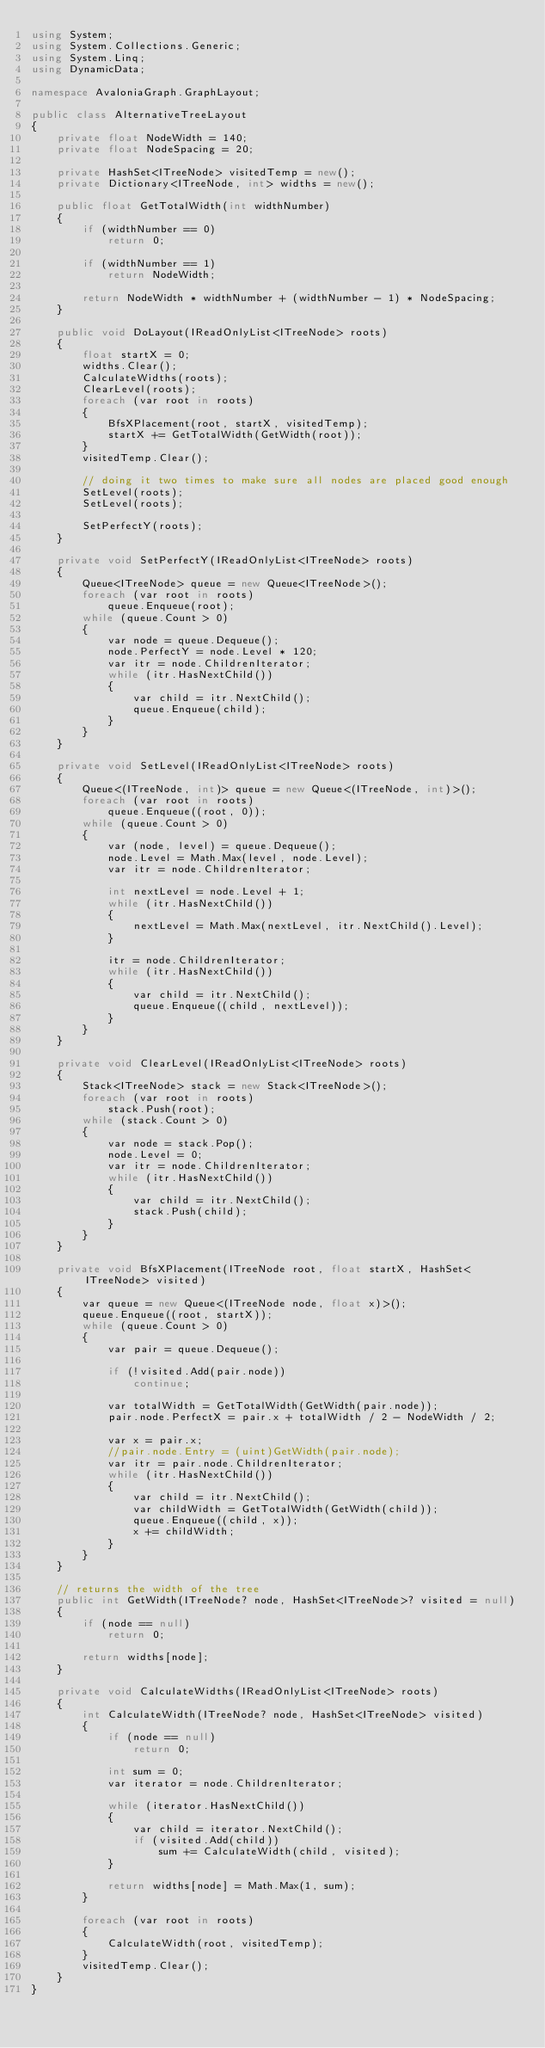Convert code to text. <code><loc_0><loc_0><loc_500><loc_500><_C#_>using System;
using System.Collections.Generic;
using System.Linq;
using DynamicData;

namespace AvaloniaGraph.GraphLayout;

public class AlternativeTreeLayout
{
    private float NodeWidth = 140;
    private float NodeSpacing = 20;

    private HashSet<ITreeNode> visitedTemp = new();
    private Dictionary<ITreeNode, int> widths = new();

    public float GetTotalWidth(int widthNumber)
    {
        if (widthNumber == 0)
            return 0;
        
        if (widthNumber == 1)
            return NodeWidth;

        return NodeWidth * widthNumber + (widthNumber - 1) * NodeSpacing;
    }
    
    public void DoLayout(IReadOnlyList<ITreeNode> roots)
    {
        float startX = 0;
        widths.Clear();
        CalculateWidths(roots);
        ClearLevel(roots);
        foreach (var root in roots)
        {
            BfsXPlacement(root, startX, visitedTemp);
            startX += GetTotalWidth(GetWidth(root));
        }
        visitedTemp.Clear();

        // doing it two times to make sure all nodes are placed good enough
        SetLevel(roots);
        SetLevel(roots);

        SetPerfectY(roots);
    }

    private void SetPerfectY(IReadOnlyList<ITreeNode> roots)
    {
        Queue<ITreeNode> queue = new Queue<ITreeNode>();
        foreach (var root in roots)
            queue.Enqueue(root);
        while (queue.Count > 0)
        {
            var node = queue.Dequeue();
            node.PerfectY = node.Level * 120;
            var itr = node.ChildrenIterator;
            while (itr.HasNextChild())
            {
                var child = itr.NextChild();
                queue.Enqueue(child);
            }
        }
    }
    
    private void SetLevel(IReadOnlyList<ITreeNode> roots)
    {
        Queue<(ITreeNode, int)> queue = new Queue<(ITreeNode, int)>();
        foreach (var root in roots)
            queue.Enqueue((root, 0));
        while (queue.Count > 0)
        {
            var (node, level) = queue.Dequeue();
            node.Level = Math.Max(level, node.Level);
            var itr = node.ChildrenIterator;

            int nextLevel = node.Level + 1;
            while (itr.HasNextChild())
            {
                nextLevel = Math.Max(nextLevel, itr.NextChild().Level);
            }

            itr = node.ChildrenIterator;
            while (itr.HasNextChild())
            {
                var child = itr.NextChild();
                queue.Enqueue((child, nextLevel));
            }
        }
    }

    private void ClearLevel(IReadOnlyList<ITreeNode> roots)
    {
        Stack<ITreeNode> stack = new Stack<ITreeNode>();
        foreach (var root in roots)
            stack.Push(root);
        while (stack.Count > 0)
        {
            var node = stack.Pop();
            node.Level = 0;
            var itr = node.ChildrenIterator;
            while (itr.HasNextChild())
            {
                var child = itr.NextChild();
                stack.Push(child);
            }
        }
    }
    
    private void BfsXPlacement(ITreeNode root, float startX, HashSet<ITreeNode> visited)
    {
        var queue = new Queue<(ITreeNode node, float x)>();
        queue.Enqueue((root, startX));
        while (queue.Count > 0)
        {
            var pair = queue.Dequeue();
            
            if (!visited.Add(pair.node))
                continue;

            var totalWidth = GetTotalWidth(GetWidth(pair.node));
            pair.node.PerfectX = pair.x + totalWidth / 2 - NodeWidth / 2;

            var x = pair.x;
            //pair.node.Entry = (uint)GetWidth(pair.node);
            var itr = pair.node.ChildrenIterator;
            while (itr.HasNextChild())
            {
                var child = itr.NextChild();
                var childWidth = GetTotalWidth(GetWidth(child));
                queue.Enqueue((child, x));
                x += childWidth;
            }
        }
    }

    // returns the width of the tree
    public int GetWidth(ITreeNode? node, HashSet<ITreeNode>? visited = null)
    {
        if (node == null)
            return 0;

        return widths[node];
    }
    
    private void CalculateWidths(IReadOnlyList<ITreeNode> roots)
    {
        int CalculateWidth(ITreeNode? node, HashSet<ITreeNode> visited)
        {
            if (node == null)
                return 0;

            int sum = 0;
            var iterator = node.ChildrenIterator;
            
            while (iterator.HasNextChild())
            {
                var child = iterator.NextChild();
                if (visited.Add(child))
                    sum += CalculateWidth(child, visited);
            }

            return widths[node] = Math.Max(1, sum);
        }
        
        foreach (var root in roots)
        {
            CalculateWidth(root, visitedTemp);
        }
        visitedTemp.Clear();
    }
}</code> 